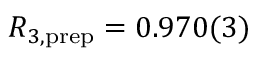<formula> <loc_0><loc_0><loc_500><loc_500>R _ { 3 , p r e p } = 0 . 9 7 0 ( 3 )</formula> 